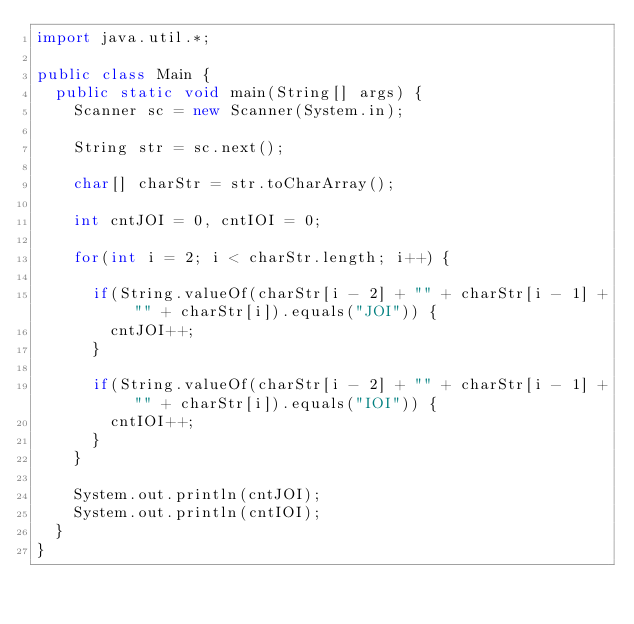Convert code to text. <code><loc_0><loc_0><loc_500><loc_500><_Java_>import java.util.*;

public class Main {
	public static void main(String[] args) {
		Scanner sc = new Scanner(System.in);

		String str = sc.next();
		
		char[] charStr = str.toCharArray();

		int cntJOI = 0, cntIOI = 0;
		
		for(int i = 2; i < charStr.length; i++) {
			
			if(String.valueOf(charStr[i - 2] + "" + charStr[i - 1] + "" + charStr[i]).equals("JOI")) {
				cntJOI++;
			}
			
			if(String.valueOf(charStr[i - 2] + "" + charStr[i - 1] + "" + charStr[i]).equals("IOI")) {
				cntIOI++;
			}
		}
		
		System.out.println(cntJOI);
		System.out.println(cntIOI);
	}
}</code> 